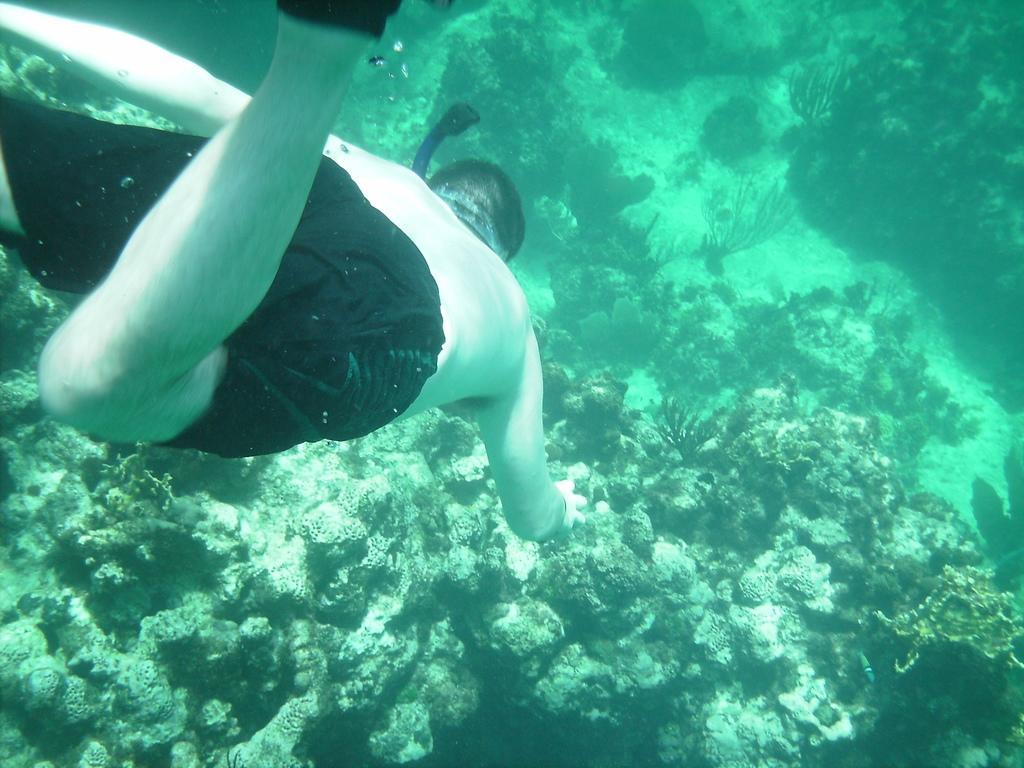In one or two sentences, can you explain what this image depicts? In this picture we can see a person and the grass in water. 